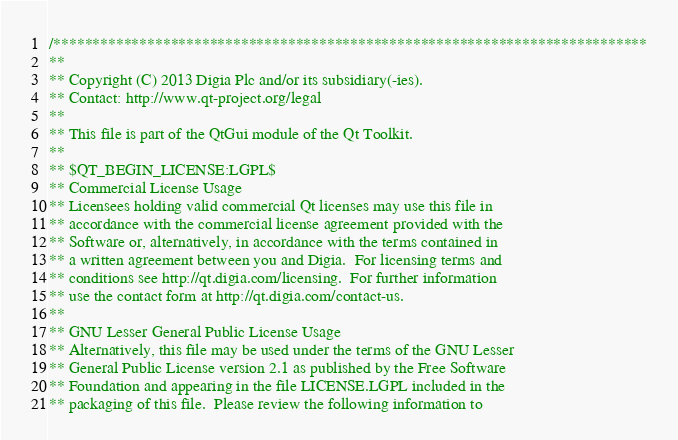<code> <loc_0><loc_0><loc_500><loc_500><_C++_>/****************************************************************************
**
** Copyright (C) 2013 Digia Plc and/or its subsidiary(-ies).
** Contact: http://www.qt-project.org/legal
**
** This file is part of the QtGui module of the Qt Toolkit.
**
** $QT_BEGIN_LICENSE:LGPL$
** Commercial License Usage
** Licensees holding valid commercial Qt licenses may use this file in
** accordance with the commercial license agreement provided with the
** Software or, alternatively, in accordance with the terms contained in
** a written agreement between you and Digia.  For licensing terms and
** conditions see http://qt.digia.com/licensing.  For further information
** use the contact form at http://qt.digia.com/contact-us.
**
** GNU Lesser General Public License Usage
** Alternatively, this file may be used under the terms of the GNU Lesser
** General Public License version 2.1 as published by the Free Software
** Foundation and appearing in the file LICENSE.LGPL included in the
** packaging of this file.  Please review the following information to</code> 